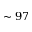<formula> <loc_0><loc_0><loc_500><loc_500>\sim 9 7</formula> 